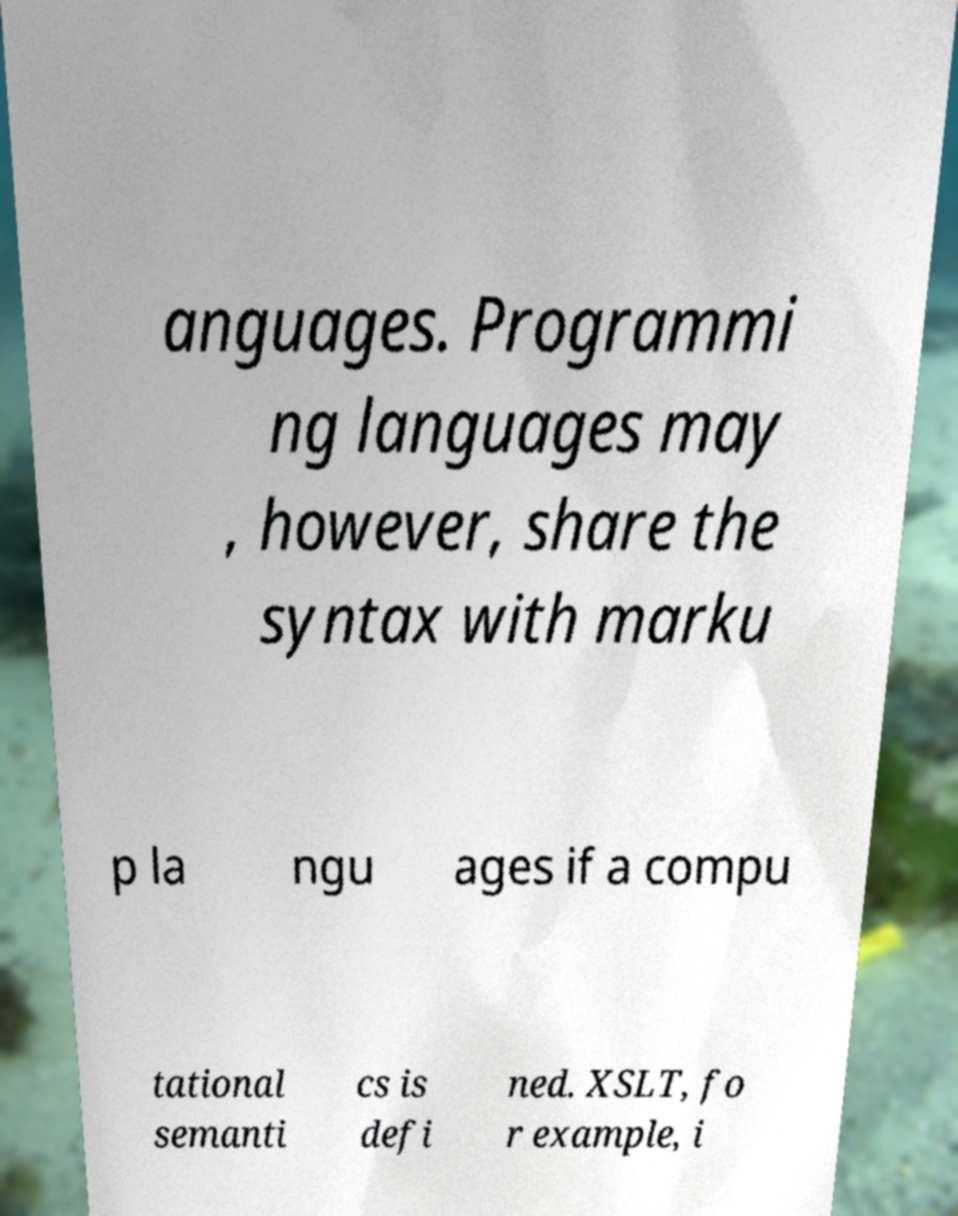Can you accurately transcribe the text from the provided image for me? anguages. Programmi ng languages may , however, share the syntax with marku p la ngu ages if a compu tational semanti cs is defi ned. XSLT, fo r example, i 